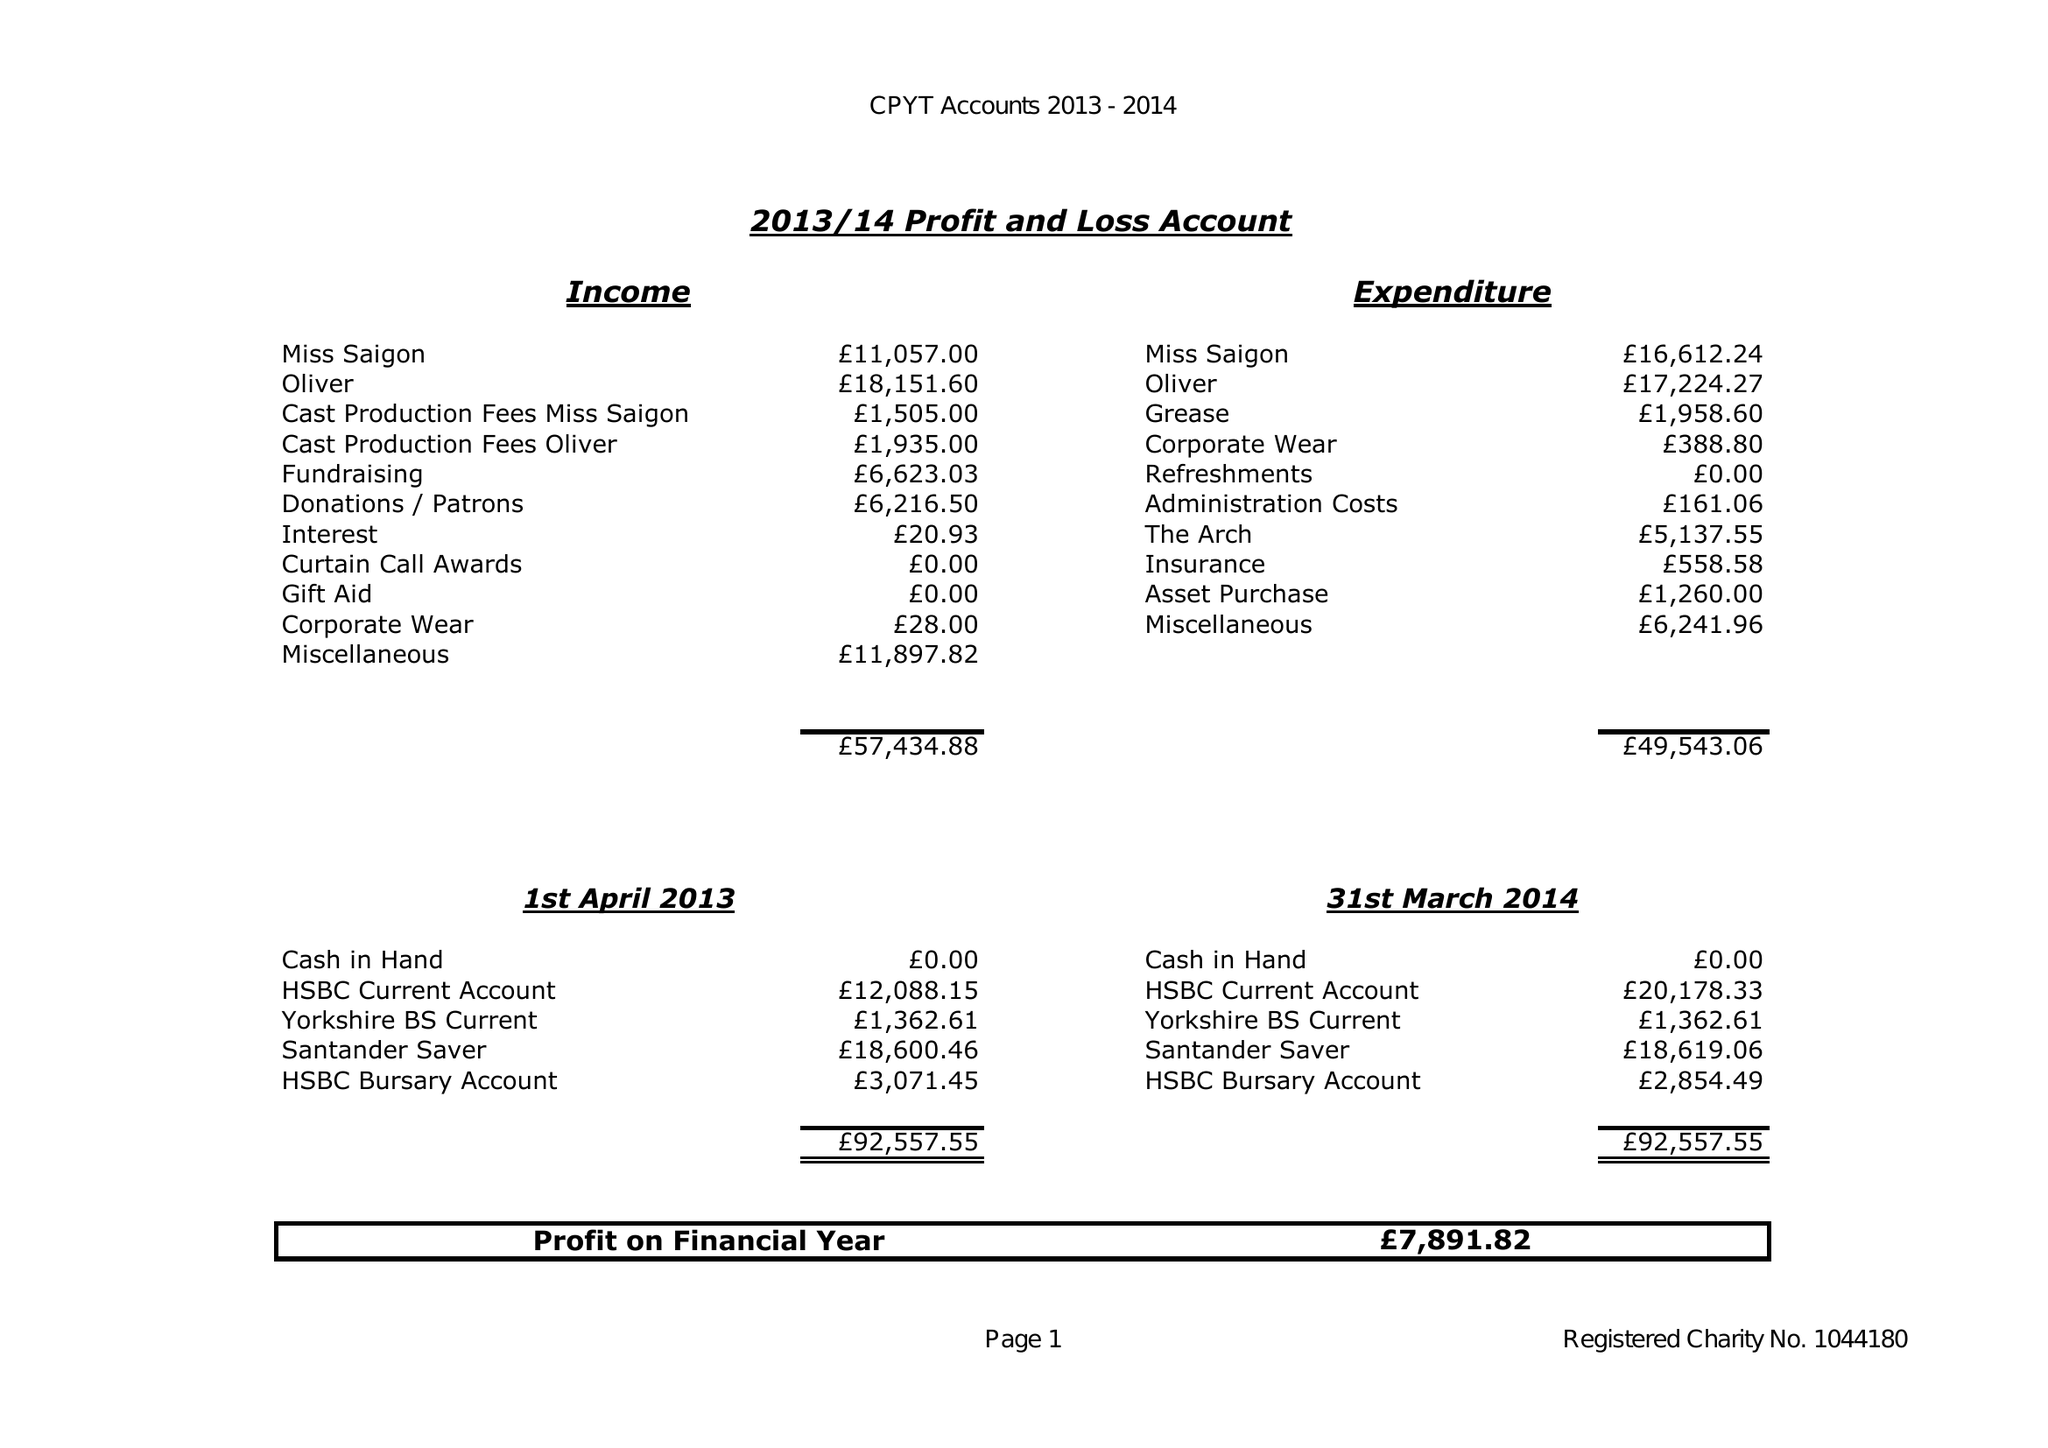What is the value for the address__post_town?
Answer the question using a single word or phrase. SOUTHAMPTON 